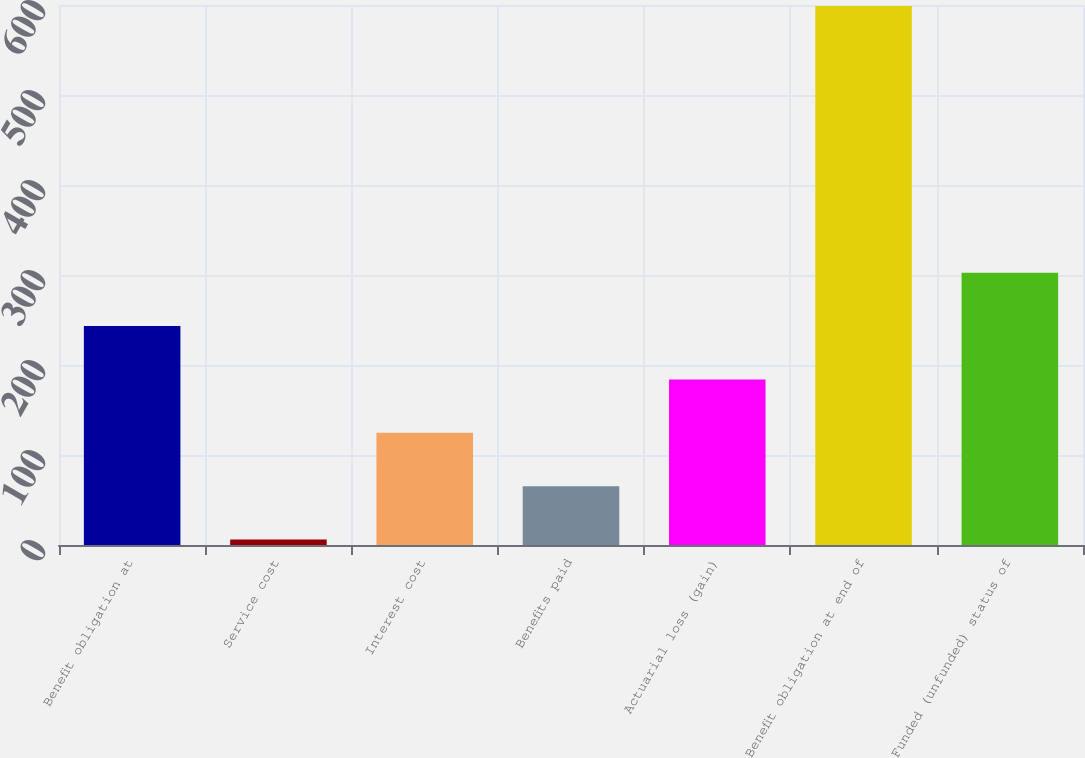Convert chart to OTSL. <chart><loc_0><loc_0><loc_500><loc_500><bar_chart><fcel>Benefit obligation at<fcel>Service cost<fcel>Interest cost<fcel>Benefits paid<fcel>Actuarial loss (gain)<fcel>Benefit obligation at end of<fcel>Funded (unfunded) status of<nl><fcel>243.2<fcel>6<fcel>124.6<fcel>65.3<fcel>183.9<fcel>599<fcel>302.5<nl></chart> 